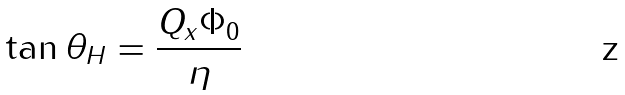Convert formula to latex. <formula><loc_0><loc_0><loc_500><loc_500>\tan \theta _ { H } = \frac { Q _ { x } \Phi _ { 0 } } { \eta }</formula> 